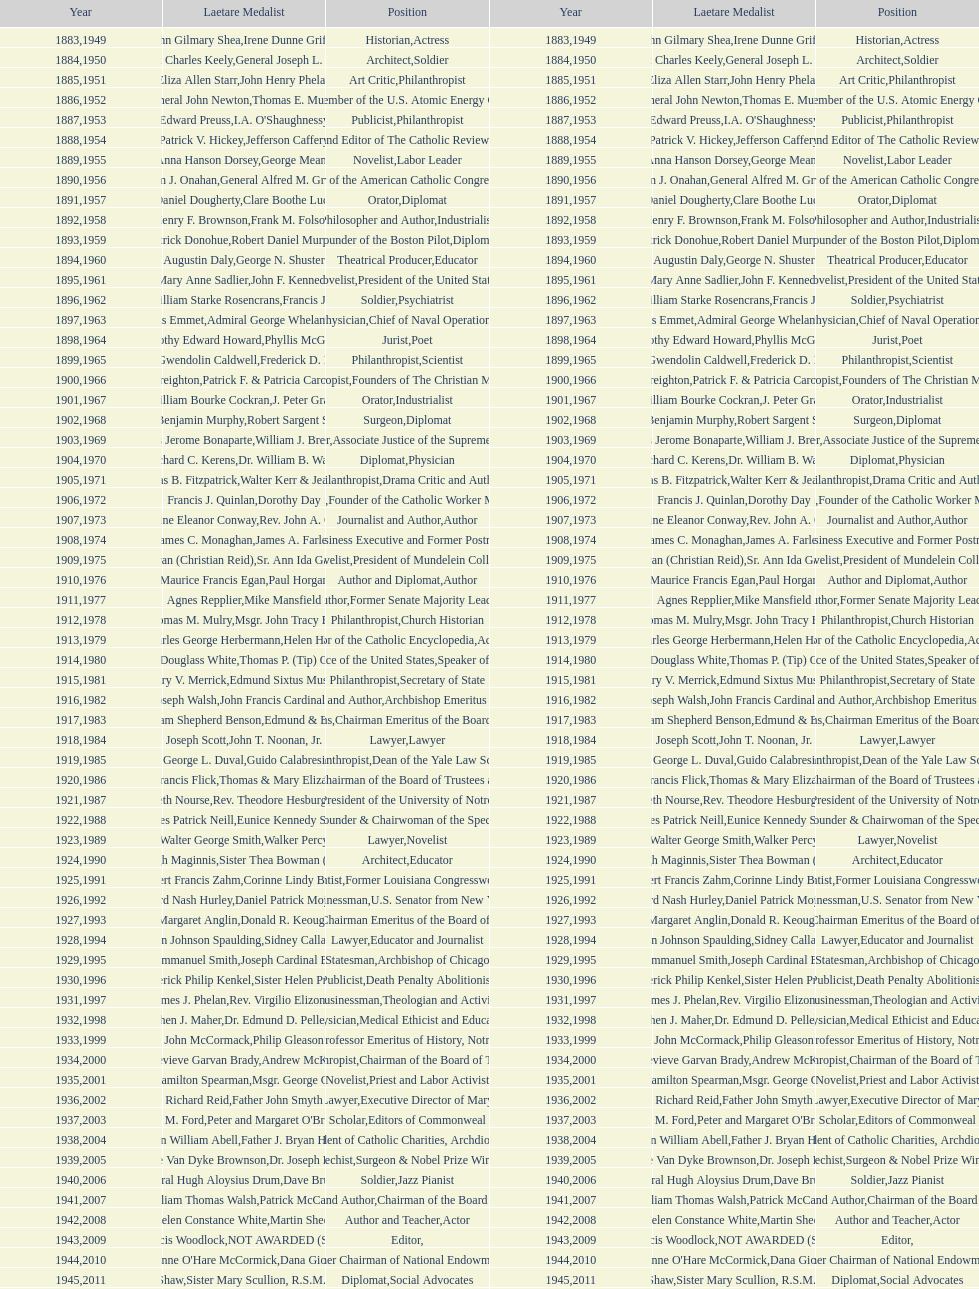Who has achieved this medal and the nobel prize simultaneously? Dr. Joseph E. Murray. 